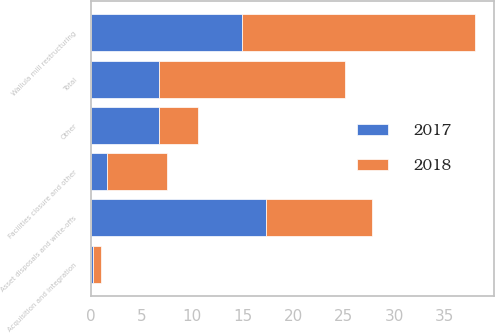<chart> <loc_0><loc_0><loc_500><loc_500><stacked_bar_chart><ecel><fcel>Asset disposals and write-offs<fcel>Wallula mill restructuring<fcel>Facilities closure and other<fcel>Acquisition and integration<fcel>Other<fcel>Total<nl><fcel>2017<fcel>17.3<fcel>14.9<fcel>1.6<fcel>0.2<fcel>6.7<fcel>6.7<nl><fcel>2018<fcel>10.5<fcel>23.1<fcel>5.9<fcel>0.8<fcel>3.9<fcel>18.4<nl></chart> 